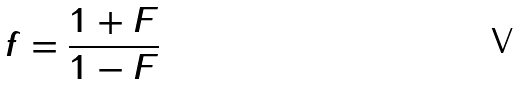Convert formula to latex. <formula><loc_0><loc_0><loc_500><loc_500>f = \frac { 1 + F } { 1 - F }</formula> 